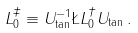<formula> <loc_0><loc_0><loc_500><loc_500>L _ { 0 } ^ { \ddag } \equiv U _ { \tan } ^ { - 1 } \L L _ { 0 } ^ { \dagger } U _ { \tan } \, .</formula> 